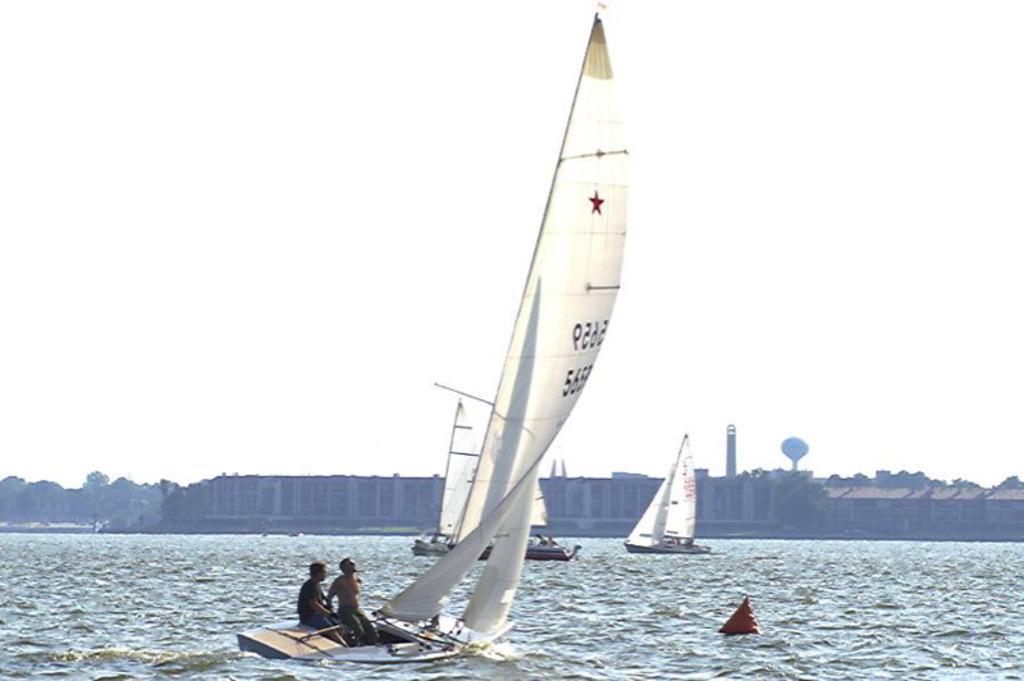Please provide a concise description of this image. In this image we can see few boats on the water, there are two persons sitting in a boat and there are few buildings, trees and the sky in the background. 